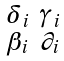<formula> <loc_0><loc_0><loc_500><loc_500>\begin{smallmatrix} \delta _ { i } & \gamma _ { i } \\ \beta _ { i } & \partial _ { i } \end{smallmatrix}</formula> 